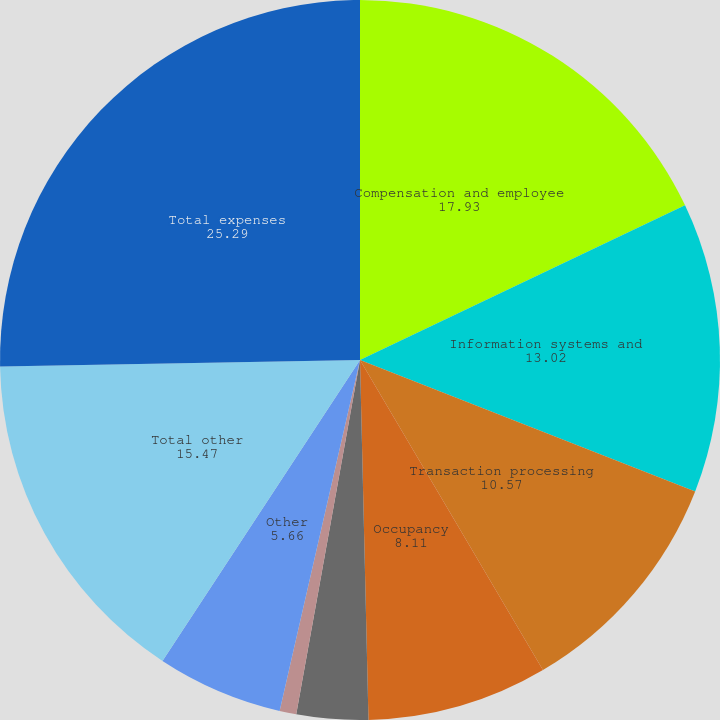Convert chart to OTSL. <chart><loc_0><loc_0><loc_500><loc_500><pie_chart><fcel>Compensation and employee<fcel>Information systems and<fcel>Transaction processing<fcel>Occupancy<fcel>Professional services<fcel>Amortization of other<fcel>Other<fcel>Total other<fcel>Total expenses<nl><fcel>17.93%<fcel>13.02%<fcel>10.57%<fcel>8.11%<fcel>3.21%<fcel>0.75%<fcel>5.66%<fcel>15.47%<fcel>25.29%<nl></chart> 